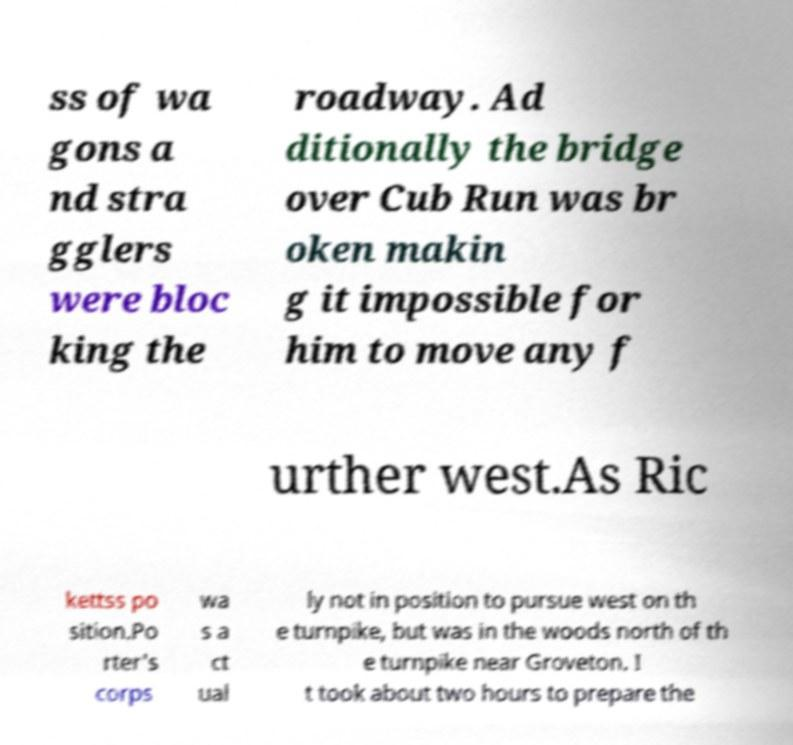There's text embedded in this image that I need extracted. Can you transcribe it verbatim? ss of wa gons a nd stra gglers were bloc king the roadway. Ad ditionally the bridge over Cub Run was br oken makin g it impossible for him to move any f urther west.As Ric kettss po sition.Po rter's corps wa s a ct ual ly not in position to pursue west on th e turnpike, but was in the woods north of th e turnpike near Groveton. I t took about two hours to prepare the 